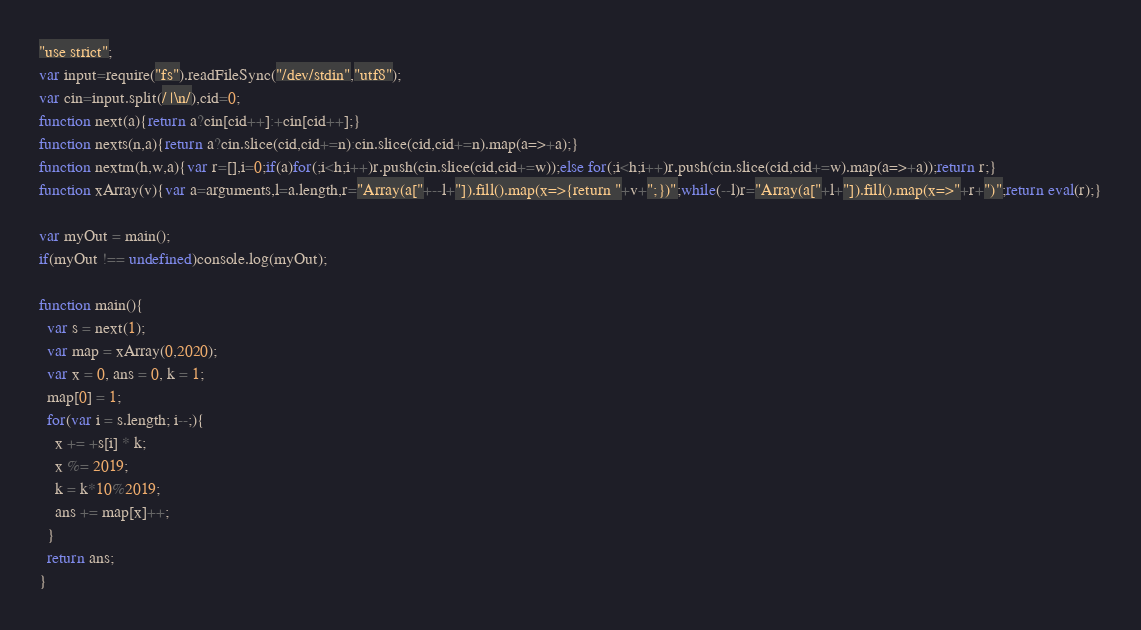Convert code to text. <code><loc_0><loc_0><loc_500><loc_500><_TypeScript_>"use strict";
var input=require("fs").readFileSync("/dev/stdin","utf8");
var cin=input.split(/ |\n/),cid=0;
function next(a){return a?cin[cid++]:+cin[cid++];}
function nexts(n,a){return a?cin.slice(cid,cid+=n):cin.slice(cid,cid+=n).map(a=>+a);}
function nextm(h,w,a){var r=[],i=0;if(a)for(;i<h;i++)r.push(cin.slice(cid,cid+=w));else for(;i<h;i++)r.push(cin.slice(cid,cid+=w).map(a=>+a));return r;}
function xArray(v){var a=arguments,l=a.length,r="Array(a["+--l+"]).fill().map(x=>{return "+v+";})";while(--l)r="Array(a["+l+"]).fill().map(x=>"+r+")";return eval(r);}

var myOut = main();
if(myOut !== undefined)console.log(myOut);

function main(){
  var s = next(1);
  var map = xArray(0,2020);
  var x = 0, ans = 0, k = 1;
  map[0] = 1;
  for(var i = s.length; i--;){
    x += +s[i] * k;
    x %= 2019;
    k = k*10%2019;
    ans += map[x]++;
  }
  return ans;
}
</code> 